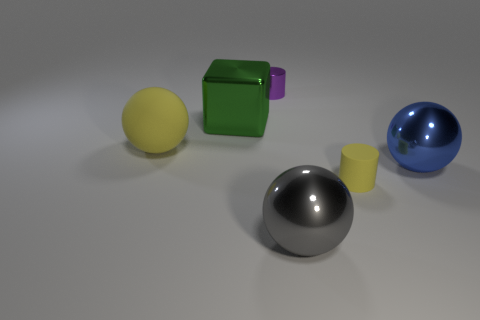There is a matte object that is to the left of the yellow matte cylinder; does it have the same size as the blue sphere that is in front of the large green cube?
Ensure brevity in your answer.  Yes. There is a large shiny sphere that is behind the tiny cylinder in front of the tiny thing that is behind the large yellow ball; what color is it?
Offer a terse response. Blue. Is there a red thing of the same shape as the tiny purple object?
Ensure brevity in your answer.  No. Are there more green metal objects that are in front of the small yellow object than small yellow cylinders?
Offer a terse response. No. What number of rubber things are yellow spheres or large gray objects?
Ensure brevity in your answer.  1. There is a ball that is both behind the yellow cylinder and left of the large blue metal sphere; how big is it?
Ensure brevity in your answer.  Large. Are there any small things behind the thing that is on the right side of the tiny yellow matte object?
Your answer should be compact. Yes. There is a big rubber sphere; what number of shiny things are in front of it?
Provide a succinct answer. 2. What color is the other tiny object that is the same shape as the small shiny thing?
Ensure brevity in your answer.  Yellow. Do the small thing that is in front of the big matte thing and the blue thing right of the yellow rubber ball have the same material?
Give a very brief answer. No. 